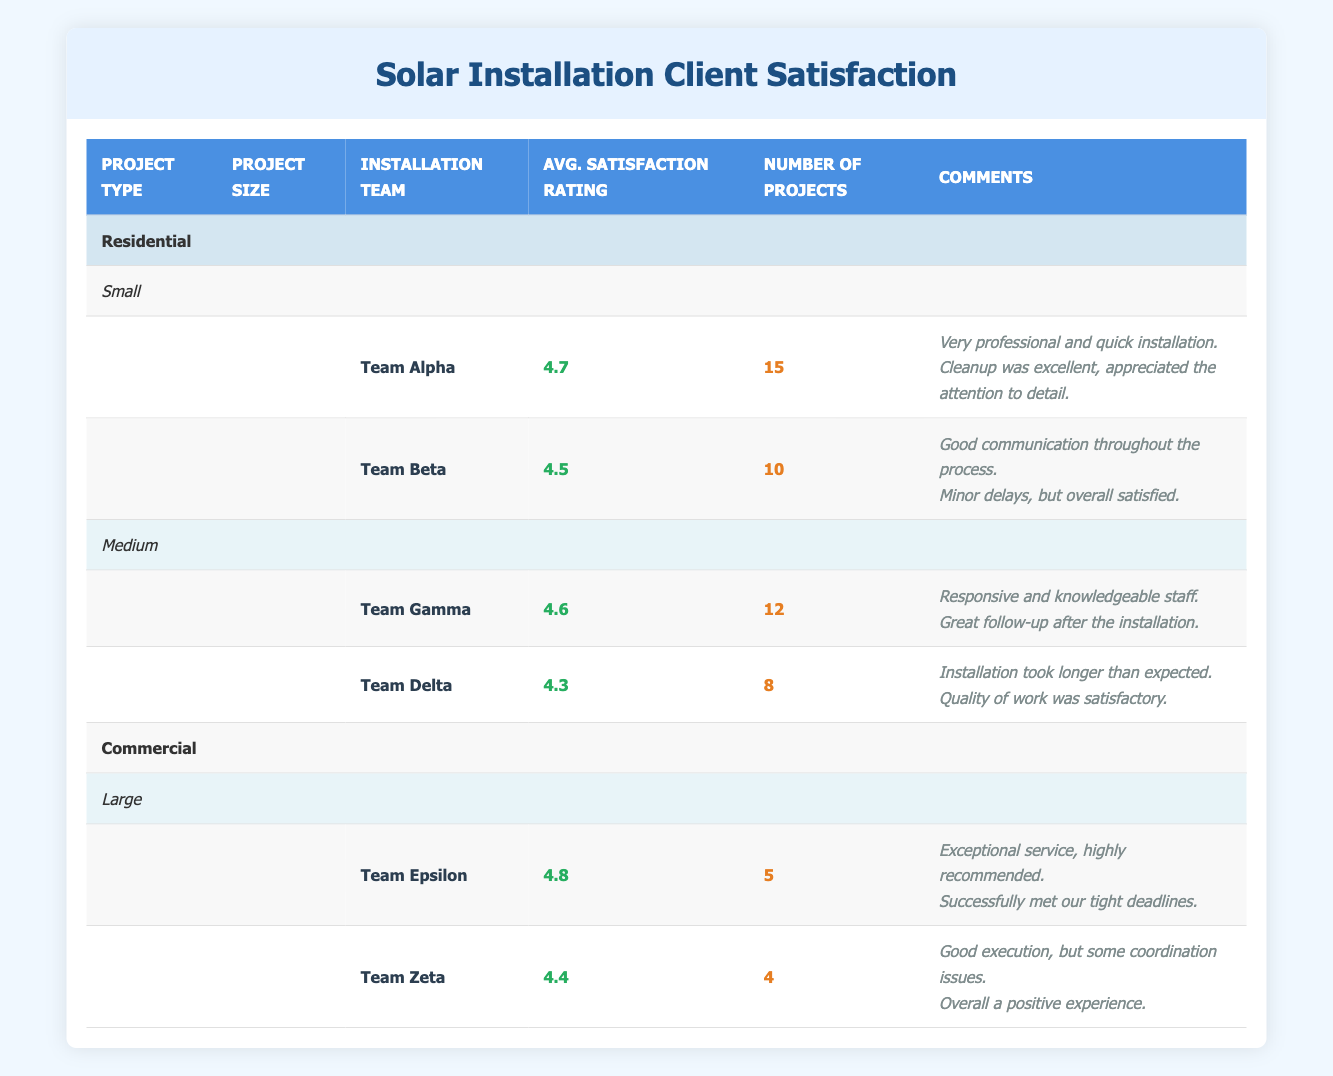What is the average satisfaction rating for Team Alpha? The table indicates that Team Alpha has an average satisfaction rating of 4.7. This is found directly in the “Average Satisfaction Rating” column under the row for Team Alpha in the "Small" project size for Residential installations.
Answer: 4.7 How many projects did Team Gamma complete? The table states that Team Gamma completed a total of 12 projects, listed under the “Number of Projects” column. This can be directly retrieved from the relevant row for Team Gamma in the “Medium” project size for Residential installations.
Answer: 12 Which installation team had the highest average satisfaction rating in the Commercial category? Looking at the “Commercial” category, Team Epsilon has the highest average satisfaction rating of 4.8. This is found in the “Average Satisfaction Rating” column under the row for Team Epsilon in the "Large" project size.
Answer: Team Epsilon What is the average satisfaction rating for all teams in the Residential Small category? To find the average satisfaction rating for the teams in this category, calculate the average of 4.7 (Team Alpha) and 4.5 (Team Beta): (4.7 + 4.5) / 2 = 4.6. This is done by summing the average satisfaction ratings and dividing by the number of teams.
Answer: 4.6 Did Team Zeta complete more projects than Team Epsilon? Team Zeta completed 4 projects while Team Epsilon completed 5 projects, which means Team Zeta did not complete more projects than Team Epsilon. This comparison is derived from the “Number of Projects” column in their respective rows.
Answer: No What is the total number of projects completed by all teams in the Residential category? The total number of projects for Residential installations can be calculated by adding the number of projects completed by Team Alpha (15) + Team Beta (10) + Team Gamma (12) + Team Delta (8). This totals to 15 + 10 + 12 + 8 = 45.
Answer: 45 Which team had the lowest average satisfaction rating in the Residential category? In the Residential category, Team Delta has the lowest average satisfaction rating of 4.3, which can be found in the “Average Satisfaction Rating” column under Team Delta in the “Medium” project size row.
Answer: Team Delta What is the difference in average satisfaction ratings between Team Epsilon and Team Beta? Team Epsilon’s rating is 4.8 and Team Beta’s is 4.5. Subtract Team Beta’s rating from Team Epsilon’s: 4.8 - 4.5 = 0.3. This gives the difference in their satisfaction ratings.
Answer: 0.3 